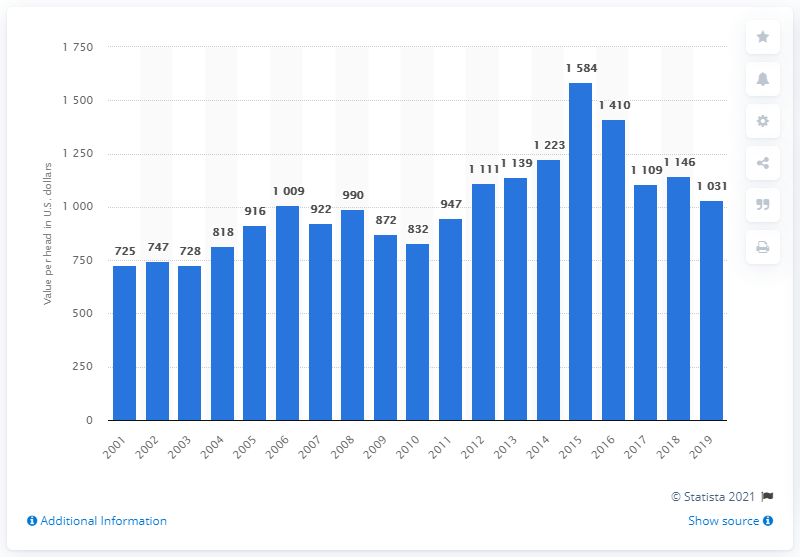Give some essential details in this illustration. In the year 2001, the average value per head of cattle and calves was 725. 